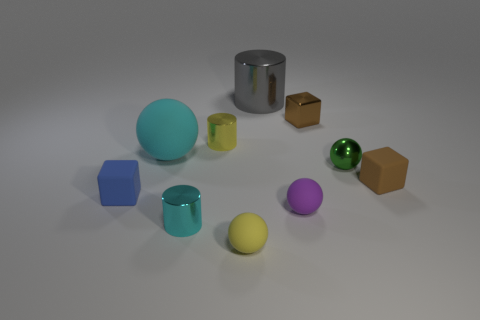Are there any other things that are made of the same material as the small yellow sphere?
Offer a very short reply. Yes. Does the cyan ball have the same material as the tiny block that is left of the purple ball?
Provide a short and direct response. Yes. There is a green shiny ball to the right of the tiny metallic cylinder right of the small cyan shiny object; what is its size?
Your response must be concise. Small. Is there any other thing that has the same color as the metal ball?
Provide a short and direct response. No. Is the cylinder in front of the tiny blue block made of the same material as the small brown thing that is behind the tiny metal sphere?
Offer a terse response. Yes. What is the ball that is to the left of the small purple thing and behind the tiny purple matte ball made of?
Ensure brevity in your answer.  Rubber. There is a big cyan thing; does it have the same shape as the tiny yellow thing in front of the cyan rubber sphere?
Give a very brief answer. Yes. What material is the cylinder in front of the small block that is on the left side of the metallic cylinder that is right of the tiny yellow matte sphere?
Provide a short and direct response. Metal. What number of other things are the same size as the gray metal thing?
Offer a very short reply. 1. There is a small metal cylinder in front of the block that is on the left side of the tiny metallic cube; what number of cyan metallic cylinders are in front of it?
Offer a very short reply. 0. 